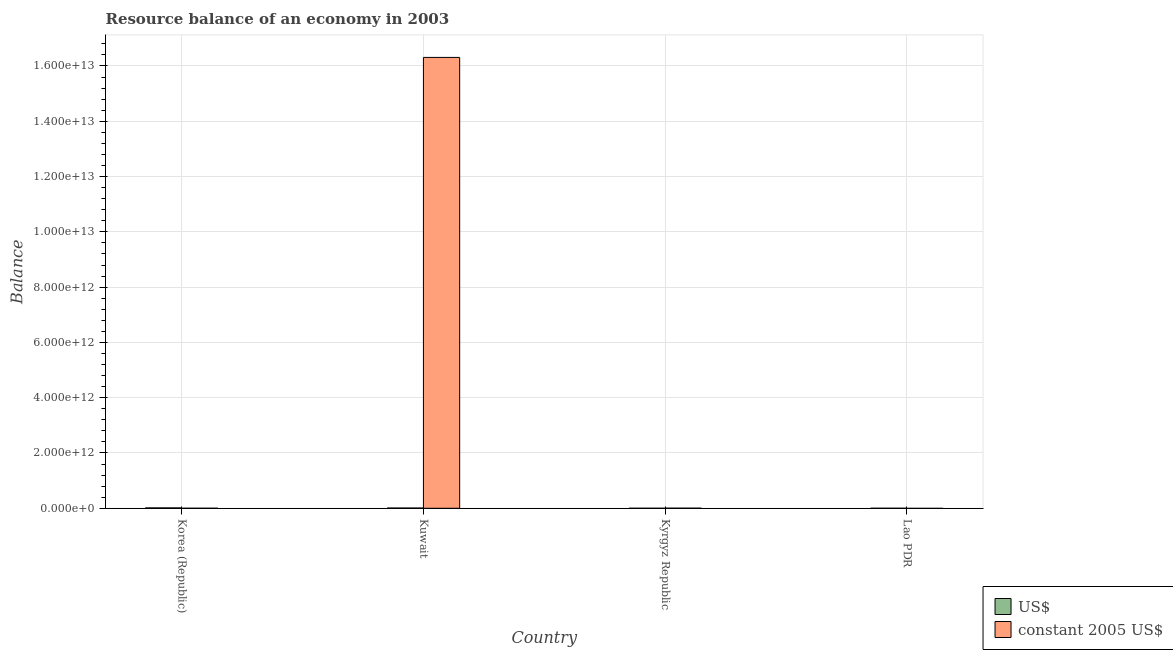How many different coloured bars are there?
Keep it short and to the point. 2. How many bars are there on the 3rd tick from the left?
Offer a terse response. 1. How many bars are there on the 4th tick from the right?
Make the answer very short. 1. What is the label of the 4th group of bars from the left?
Your answer should be very brief. Lao PDR. In how many cases, is the number of bars for a given country not equal to the number of legend labels?
Provide a succinct answer. 3. Across all countries, what is the maximum resource balance in constant us$?
Your response must be concise. 1.63e+13. Across all countries, what is the minimum resource balance in constant us$?
Provide a succinct answer. 0. In which country was the resource balance in us$ maximum?
Make the answer very short. Korea (Republic). What is the total resource balance in us$ in the graph?
Your answer should be very brief. 2.21e+1. What is the difference between the resource balance in constant us$ in Kuwait and that in Kyrgyz Republic?
Your response must be concise. 1.63e+13. What is the difference between the resource balance in us$ in Kyrgyz Republic and the resource balance in constant us$ in Kuwait?
Provide a succinct answer. -1.63e+13. What is the average resource balance in us$ per country?
Offer a terse response. 5.53e+09. What is the difference between the resource balance in constant us$ and resource balance in us$ in Kuwait?
Ensure brevity in your answer.  1.63e+13. What is the difference between the highest and the lowest resource balance in constant us$?
Ensure brevity in your answer.  1.63e+13. How many countries are there in the graph?
Provide a succinct answer. 4. What is the difference between two consecutive major ticks on the Y-axis?
Offer a terse response. 2.00e+12. Does the graph contain grids?
Offer a very short reply. Yes. Where does the legend appear in the graph?
Your response must be concise. Bottom right. How many legend labels are there?
Offer a terse response. 2. How are the legend labels stacked?
Ensure brevity in your answer.  Vertical. What is the title of the graph?
Offer a very short reply. Resource balance of an economy in 2003. Does "Urban Population" appear as one of the legend labels in the graph?
Provide a succinct answer. No. What is the label or title of the Y-axis?
Give a very brief answer. Balance. What is the Balance of US$ in Korea (Republic)?
Ensure brevity in your answer.  1.37e+1. What is the Balance of constant 2005 US$ in Korea (Republic)?
Your answer should be compact. 0. What is the Balance of US$ in Kuwait?
Make the answer very short. 8.44e+09. What is the Balance of constant 2005 US$ in Kuwait?
Offer a terse response. 1.63e+13. What is the Balance of constant 2005 US$ in Kyrgyz Republic?
Keep it short and to the point. 2.52e+09. What is the Balance of US$ in Lao PDR?
Give a very brief answer. 0. What is the Balance in constant 2005 US$ in Lao PDR?
Provide a succinct answer. 0. Across all countries, what is the maximum Balance in US$?
Provide a short and direct response. 1.37e+1. Across all countries, what is the maximum Balance of constant 2005 US$?
Keep it short and to the point. 1.63e+13. What is the total Balance of US$ in the graph?
Your answer should be compact. 2.21e+1. What is the total Balance of constant 2005 US$ in the graph?
Ensure brevity in your answer.  1.63e+13. What is the difference between the Balance in US$ in Korea (Republic) and that in Kuwait?
Offer a very short reply. 5.25e+09. What is the difference between the Balance of constant 2005 US$ in Kuwait and that in Kyrgyz Republic?
Provide a succinct answer. 1.63e+13. What is the difference between the Balance of US$ in Korea (Republic) and the Balance of constant 2005 US$ in Kuwait?
Give a very brief answer. -1.63e+13. What is the difference between the Balance of US$ in Korea (Republic) and the Balance of constant 2005 US$ in Kyrgyz Republic?
Your answer should be compact. 1.12e+1. What is the difference between the Balance in US$ in Kuwait and the Balance in constant 2005 US$ in Kyrgyz Republic?
Provide a short and direct response. 5.92e+09. What is the average Balance of US$ per country?
Your answer should be compact. 5.53e+09. What is the average Balance in constant 2005 US$ per country?
Offer a very short reply. 4.08e+12. What is the difference between the Balance of US$ and Balance of constant 2005 US$ in Kuwait?
Offer a very short reply. -1.63e+13. What is the ratio of the Balance of US$ in Korea (Republic) to that in Kuwait?
Make the answer very short. 1.62. What is the ratio of the Balance in constant 2005 US$ in Kuwait to that in Kyrgyz Republic?
Make the answer very short. 6485.21. What is the difference between the highest and the lowest Balance in US$?
Provide a short and direct response. 1.37e+1. What is the difference between the highest and the lowest Balance in constant 2005 US$?
Provide a short and direct response. 1.63e+13. 